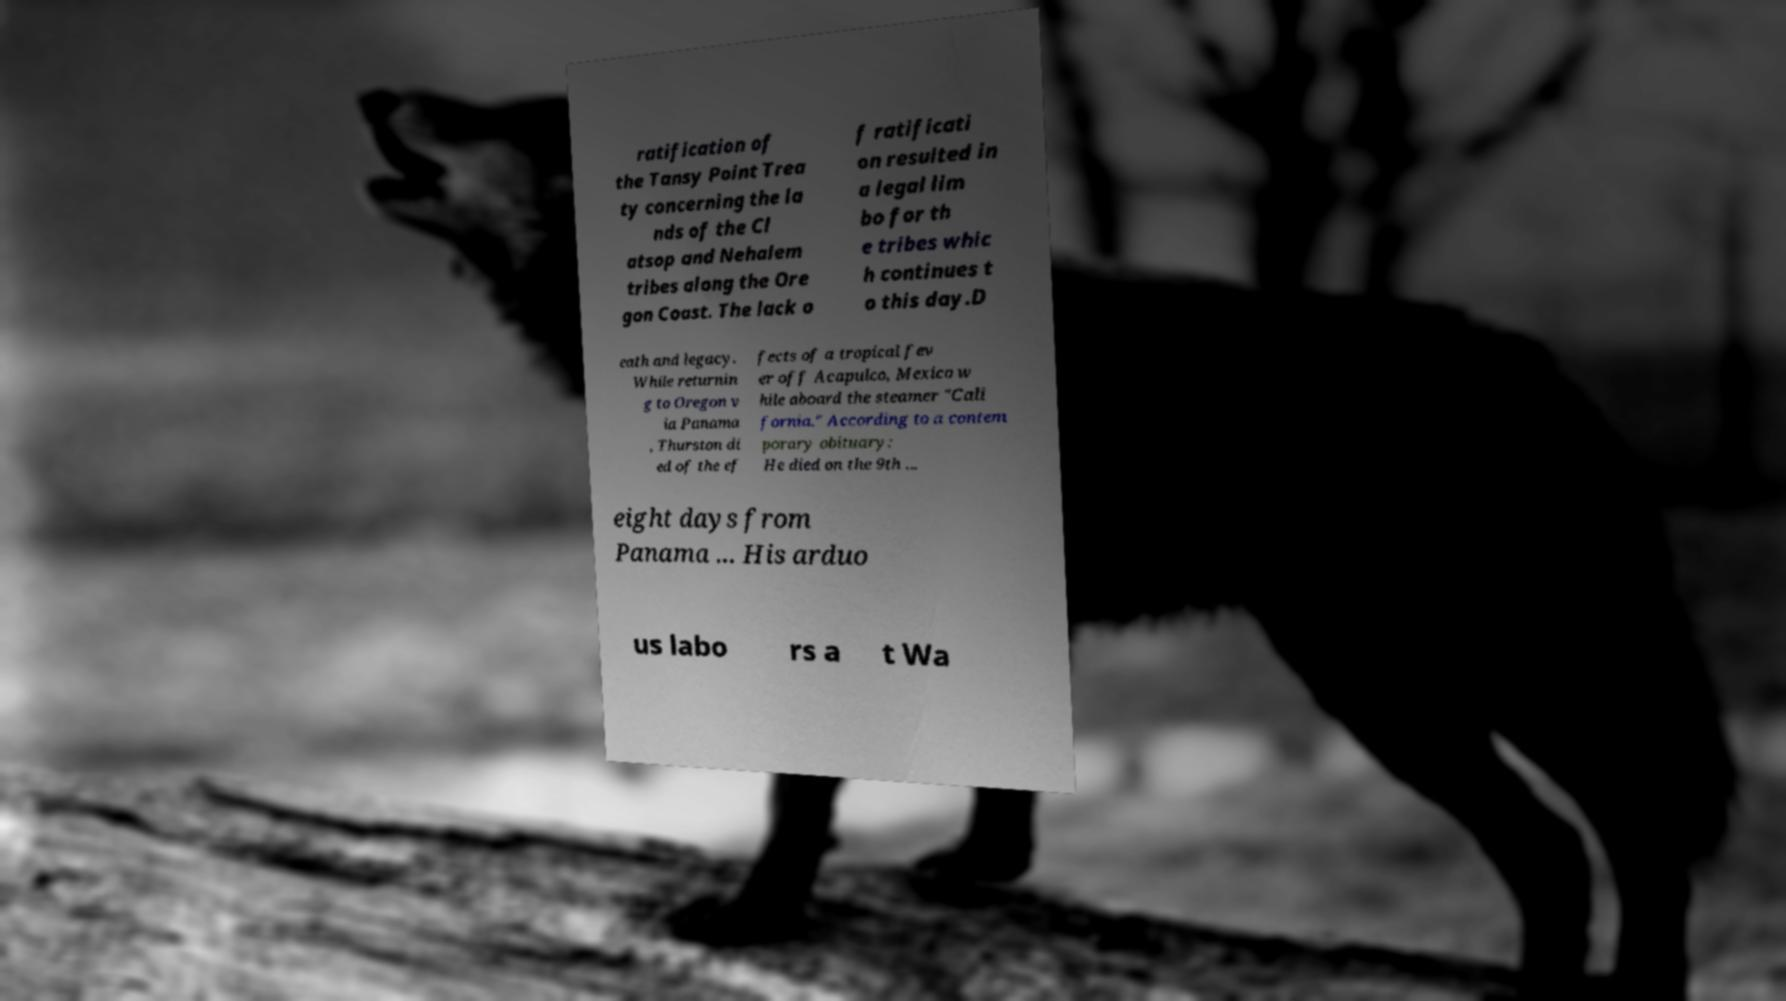I need the written content from this picture converted into text. Can you do that? ratification of the Tansy Point Trea ty concerning the la nds of the Cl atsop and Nehalem tribes along the Ore gon Coast. The lack o f ratificati on resulted in a legal lim bo for th e tribes whic h continues t o this day.D eath and legacy. While returnin g to Oregon v ia Panama , Thurston di ed of the ef fects of a tropical fev er off Acapulco, Mexico w hile aboard the steamer "Cali fornia." According to a contem porary obituary: He died on the 9th ... eight days from Panama ... His arduo us labo rs a t Wa 